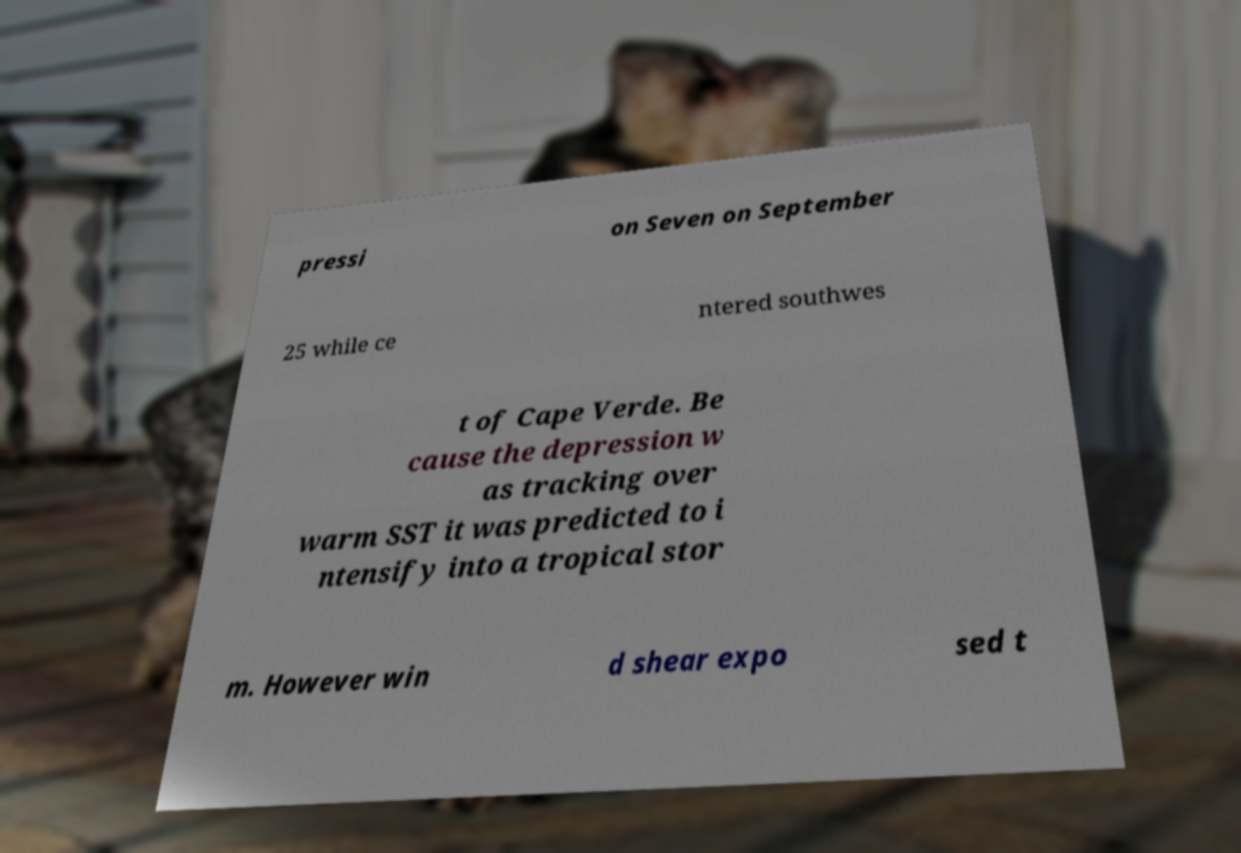There's text embedded in this image that I need extracted. Can you transcribe it verbatim? pressi on Seven on September 25 while ce ntered southwes t of Cape Verde. Be cause the depression w as tracking over warm SST it was predicted to i ntensify into a tropical stor m. However win d shear expo sed t 